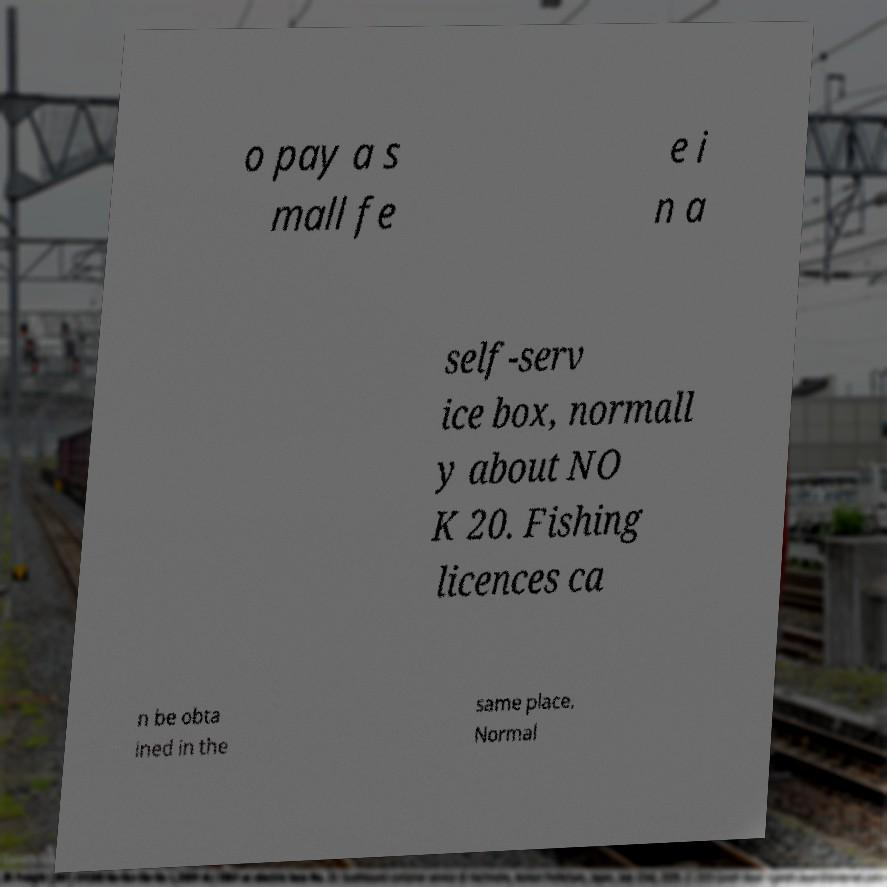For documentation purposes, I need the text within this image transcribed. Could you provide that? o pay a s mall fe e i n a self-serv ice box, normall y about NO K 20. Fishing licences ca n be obta ined in the same place. Normal 